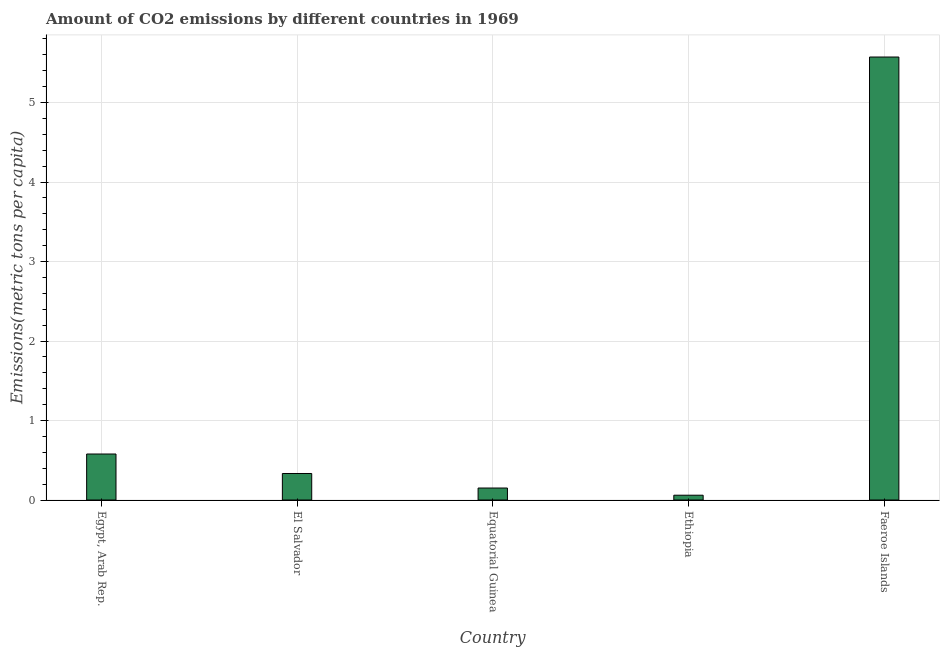What is the title of the graph?
Your answer should be compact. Amount of CO2 emissions by different countries in 1969. What is the label or title of the Y-axis?
Your answer should be very brief. Emissions(metric tons per capita). What is the amount of co2 emissions in Egypt, Arab Rep.?
Provide a succinct answer. 0.58. Across all countries, what is the maximum amount of co2 emissions?
Your answer should be very brief. 5.57. Across all countries, what is the minimum amount of co2 emissions?
Ensure brevity in your answer.  0.06. In which country was the amount of co2 emissions maximum?
Your answer should be very brief. Faeroe Islands. In which country was the amount of co2 emissions minimum?
Your answer should be compact. Ethiopia. What is the sum of the amount of co2 emissions?
Keep it short and to the point. 6.7. What is the difference between the amount of co2 emissions in El Salvador and Faeroe Islands?
Provide a short and direct response. -5.24. What is the average amount of co2 emissions per country?
Your response must be concise. 1.34. What is the median amount of co2 emissions?
Ensure brevity in your answer.  0.33. In how many countries, is the amount of co2 emissions greater than 4.4 metric tons per capita?
Your answer should be very brief. 1. What is the ratio of the amount of co2 emissions in Egypt, Arab Rep. to that in El Salvador?
Your response must be concise. 1.74. Is the difference between the amount of co2 emissions in El Salvador and Equatorial Guinea greater than the difference between any two countries?
Make the answer very short. No. What is the difference between the highest and the second highest amount of co2 emissions?
Offer a very short reply. 4.99. Is the sum of the amount of co2 emissions in Egypt, Arab Rep. and Equatorial Guinea greater than the maximum amount of co2 emissions across all countries?
Make the answer very short. No. What is the difference between the highest and the lowest amount of co2 emissions?
Give a very brief answer. 5.51. How many bars are there?
Offer a very short reply. 5. How many countries are there in the graph?
Offer a very short reply. 5. What is the difference between two consecutive major ticks on the Y-axis?
Make the answer very short. 1. What is the Emissions(metric tons per capita) in Egypt, Arab Rep.?
Provide a short and direct response. 0.58. What is the Emissions(metric tons per capita) in El Salvador?
Provide a short and direct response. 0.33. What is the Emissions(metric tons per capita) of Equatorial Guinea?
Make the answer very short. 0.15. What is the Emissions(metric tons per capita) of Ethiopia?
Give a very brief answer. 0.06. What is the Emissions(metric tons per capita) of Faeroe Islands?
Provide a succinct answer. 5.57. What is the difference between the Emissions(metric tons per capita) in Egypt, Arab Rep. and El Salvador?
Offer a terse response. 0.25. What is the difference between the Emissions(metric tons per capita) in Egypt, Arab Rep. and Equatorial Guinea?
Offer a very short reply. 0.43. What is the difference between the Emissions(metric tons per capita) in Egypt, Arab Rep. and Ethiopia?
Provide a short and direct response. 0.52. What is the difference between the Emissions(metric tons per capita) in Egypt, Arab Rep. and Faeroe Islands?
Give a very brief answer. -4.99. What is the difference between the Emissions(metric tons per capita) in El Salvador and Equatorial Guinea?
Your answer should be very brief. 0.18. What is the difference between the Emissions(metric tons per capita) in El Salvador and Ethiopia?
Give a very brief answer. 0.27. What is the difference between the Emissions(metric tons per capita) in El Salvador and Faeroe Islands?
Make the answer very short. -5.24. What is the difference between the Emissions(metric tons per capita) in Equatorial Guinea and Ethiopia?
Your response must be concise. 0.09. What is the difference between the Emissions(metric tons per capita) in Equatorial Guinea and Faeroe Islands?
Your answer should be compact. -5.42. What is the difference between the Emissions(metric tons per capita) in Ethiopia and Faeroe Islands?
Give a very brief answer. -5.51. What is the ratio of the Emissions(metric tons per capita) in Egypt, Arab Rep. to that in El Salvador?
Offer a terse response. 1.74. What is the ratio of the Emissions(metric tons per capita) in Egypt, Arab Rep. to that in Equatorial Guinea?
Provide a succinct answer. 3.84. What is the ratio of the Emissions(metric tons per capita) in Egypt, Arab Rep. to that in Ethiopia?
Provide a short and direct response. 9.59. What is the ratio of the Emissions(metric tons per capita) in Egypt, Arab Rep. to that in Faeroe Islands?
Provide a succinct answer. 0.1. What is the ratio of the Emissions(metric tons per capita) in El Salvador to that in Equatorial Guinea?
Offer a terse response. 2.21. What is the ratio of the Emissions(metric tons per capita) in El Salvador to that in Ethiopia?
Offer a very short reply. 5.53. What is the ratio of the Emissions(metric tons per capita) in El Salvador to that in Faeroe Islands?
Provide a succinct answer. 0.06. What is the ratio of the Emissions(metric tons per capita) in Equatorial Guinea to that in Ethiopia?
Ensure brevity in your answer.  2.5. What is the ratio of the Emissions(metric tons per capita) in Equatorial Guinea to that in Faeroe Islands?
Offer a very short reply. 0.03. What is the ratio of the Emissions(metric tons per capita) in Ethiopia to that in Faeroe Islands?
Your response must be concise. 0.01. 